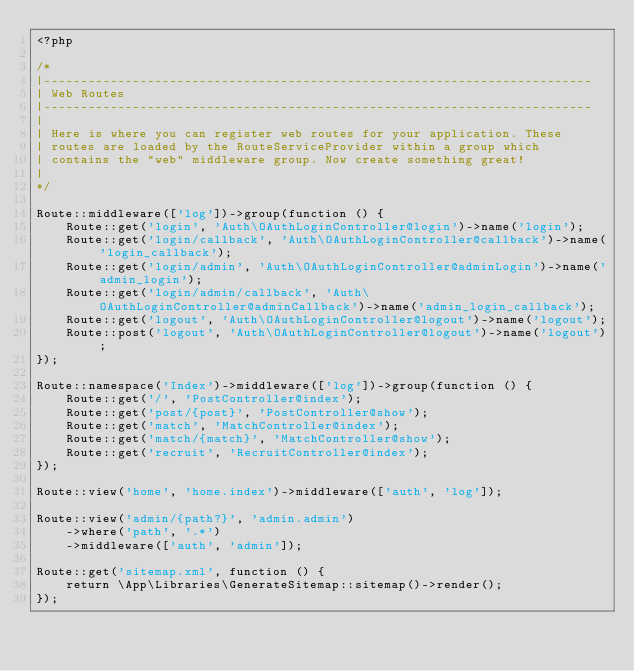<code> <loc_0><loc_0><loc_500><loc_500><_PHP_><?php

/*
|--------------------------------------------------------------------------
| Web Routes
|--------------------------------------------------------------------------
|
| Here is where you can register web routes for your application. These
| routes are loaded by the RouteServiceProvider within a group which
| contains the "web" middleware group. Now create something great!
|
*/

Route::middleware(['log'])->group(function () {
    Route::get('login', 'Auth\OAuthLoginController@login')->name('login');
    Route::get('login/callback', 'Auth\OAuthLoginController@callback')->name('login_callback');
    Route::get('login/admin', 'Auth\OAuthLoginController@adminLogin')->name('admin_login');
    Route::get('login/admin/callback', 'Auth\OAuthLoginController@adminCallback')->name('admin_login_callback');
    Route::get('logout', 'Auth\OAuthLoginController@logout')->name('logout');
    Route::post('logout', 'Auth\OAuthLoginController@logout')->name('logout');
});

Route::namespace('Index')->middleware(['log'])->group(function () {
    Route::get('/', 'PostController@index');
    Route::get('post/{post}', 'PostController@show');
    Route::get('match', 'MatchController@index');
    Route::get('match/{match}', 'MatchController@show');
    Route::get('recruit', 'RecruitController@index');
});

Route::view('home', 'home.index')->middleware(['auth', 'log']);

Route::view('admin/{path?}', 'admin.admin')
    ->where('path', '.*')
    ->middleware(['auth', 'admin']);

Route::get('sitemap.xml', function () {
    return \App\Libraries\GenerateSitemap::sitemap()->render();
});
</code> 